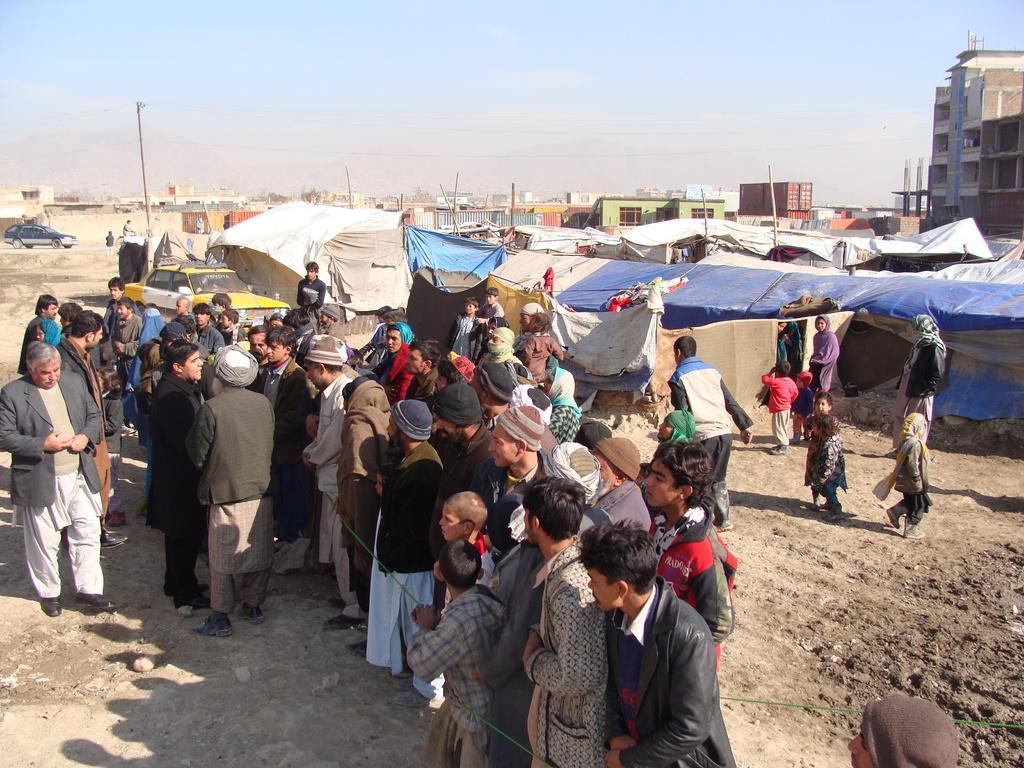How would you summarize this image in a sentence or two? In this picture there are group of people standing. At the back there are tents and buildings and there are vehicles and poles. At the top there is sky and there are wires. At the bottom there is mud. 